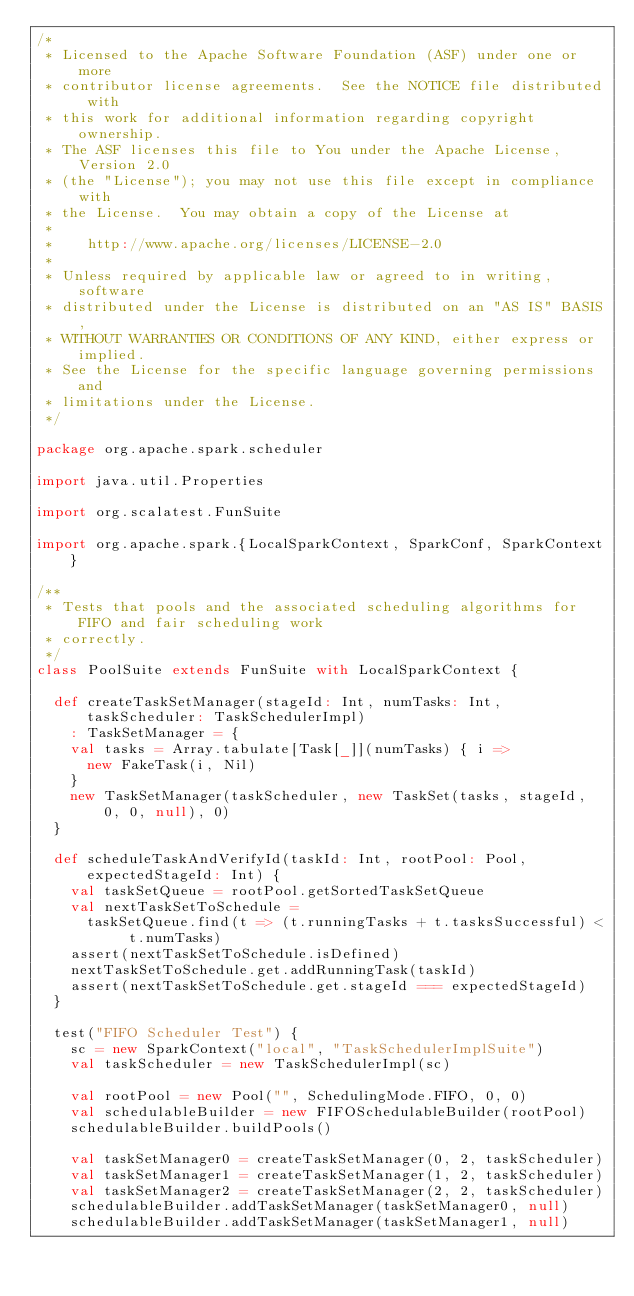<code> <loc_0><loc_0><loc_500><loc_500><_Scala_>/*
 * Licensed to the Apache Software Foundation (ASF) under one or more
 * contributor license agreements.  See the NOTICE file distributed with
 * this work for additional information regarding copyright ownership.
 * The ASF licenses this file to You under the Apache License, Version 2.0
 * (the "License"); you may not use this file except in compliance with
 * the License.  You may obtain a copy of the License at
 *
 *    http://www.apache.org/licenses/LICENSE-2.0
 *
 * Unless required by applicable law or agreed to in writing, software
 * distributed under the License is distributed on an "AS IS" BASIS,
 * WITHOUT WARRANTIES OR CONDITIONS OF ANY KIND, either express or implied.
 * See the License for the specific language governing permissions and
 * limitations under the License.
 */

package org.apache.spark.scheduler

import java.util.Properties

import org.scalatest.FunSuite

import org.apache.spark.{LocalSparkContext, SparkConf, SparkContext}

/**
 * Tests that pools and the associated scheduling algorithms for FIFO and fair scheduling work
 * correctly.
 */
class PoolSuite extends FunSuite with LocalSparkContext {

  def createTaskSetManager(stageId: Int, numTasks: Int, taskScheduler: TaskSchedulerImpl)
    : TaskSetManager = {
    val tasks = Array.tabulate[Task[_]](numTasks) { i =>
      new FakeTask(i, Nil)
    }
    new TaskSetManager(taskScheduler, new TaskSet(tasks, stageId, 0, 0, null), 0)
  }

  def scheduleTaskAndVerifyId(taskId: Int, rootPool: Pool, expectedStageId: Int) {
    val taskSetQueue = rootPool.getSortedTaskSetQueue
    val nextTaskSetToSchedule =
      taskSetQueue.find(t => (t.runningTasks + t.tasksSuccessful) < t.numTasks)
    assert(nextTaskSetToSchedule.isDefined)
    nextTaskSetToSchedule.get.addRunningTask(taskId)
    assert(nextTaskSetToSchedule.get.stageId === expectedStageId)
  }

  test("FIFO Scheduler Test") {
    sc = new SparkContext("local", "TaskSchedulerImplSuite")
    val taskScheduler = new TaskSchedulerImpl(sc)

    val rootPool = new Pool("", SchedulingMode.FIFO, 0, 0)
    val schedulableBuilder = new FIFOSchedulableBuilder(rootPool)
    schedulableBuilder.buildPools()

    val taskSetManager0 = createTaskSetManager(0, 2, taskScheduler)
    val taskSetManager1 = createTaskSetManager(1, 2, taskScheduler)
    val taskSetManager2 = createTaskSetManager(2, 2, taskScheduler)
    schedulableBuilder.addTaskSetManager(taskSetManager0, null)
    schedulableBuilder.addTaskSetManager(taskSetManager1, null)</code> 